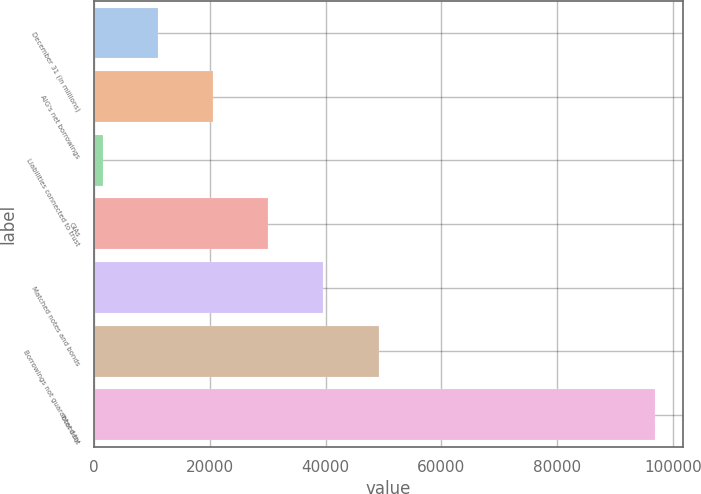Convert chart. <chart><loc_0><loc_0><loc_500><loc_500><bar_chart><fcel>December 31 (in millions)<fcel>AIG's net borrowings<fcel>Liabilities connected to trust<fcel>GIAs<fcel>Matched notes and bonds<fcel>Borrowings not guaranteed by<fcel>Total debt<nl><fcel>11030<fcel>20571<fcel>1489<fcel>30112<fcel>39653<fcel>49194<fcel>96899<nl></chart> 